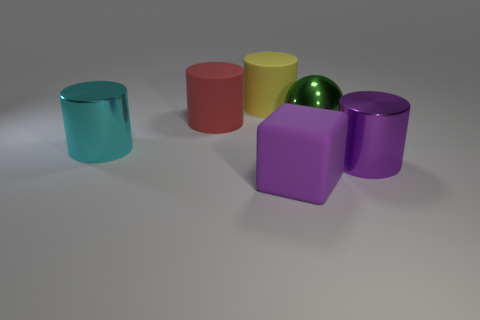Subtract all large yellow matte cylinders. How many cylinders are left? 3 Subtract all yellow cylinders. How many cylinders are left? 3 Subtract 2 cylinders. How many cylinders are left? 2 Subtract all green cylinders. Subtract all blue cubes. How many cylinders are left? 4 Add 1 large red matte things. How many objects exist? 7 Subtract all cylinders. How many objects are left? 2 Subtract all shiny cylinders. Subtract all blue rubber objects. How many objects are left? 4 Add 2 large matte cylinders. How many large matte cylinders are left? 4 Add 3 brown rubber blocks. How many brown rubber blocks exist? 3 Subtract 0 green cylinders. How many objects are left? 6 